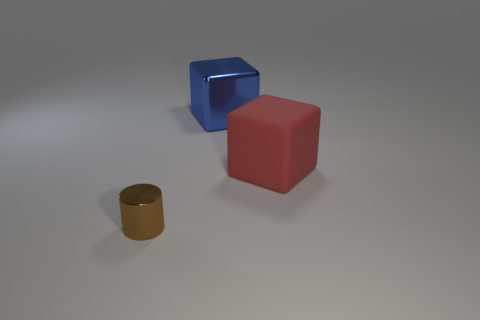How big is the cylinder?
Provide a succinct answer. Small. The red rubber object that is the same shape as the blue thing is what size?
Keep it short and to the point. Large. How many rubber objects are in front of the matte object?
Keep it short and to the point. 0. There is a object to the left of the cube that is behind the red object; what is its color?
Keep it short and to the point. Brown. Are there any other things that have the same shape as the large red rubber object?
Make the answer very short. Yes. Are there an equal number of red cubes that are in front of the red object and large rubber objects that are left of the large blue metallic block?
Provide a short and direct response. Yes. How many balls are either blue metallic things or small things?
Give a very brief answer. 0. How many other objects are the same material as the big red cube?
Keep it short and to the point. 0. There is a shiny object that is behind the brown cylinder; what shape is it?
Give a very brief answer. Cube. What material is the large object left of the big red matte cube that is on the right side of the large blue shiny thing?
Your answer should be very brief. Metal. 